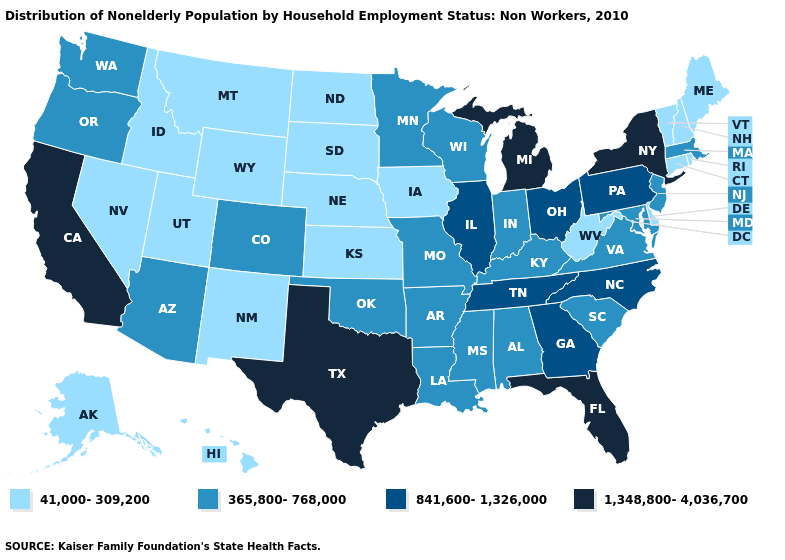What is the lowest value in the Northeast?
Answer briefly. 41,000-309,200. Which states have the highest value in the USA?
Keep it brief. California, Florida, Michigan, New York, Texas. Does New York have the highest value in the Northeast?
Give a very brief answer. Yes. Does Texas have the highest value in the USA?
Be succinct. Yes. Does the map have missing data?
Give a very brief answer. No. Name the states that have a value in the range 41,000-309,200?
Answer briefly. Alaska, Connecticut, Delaware, Hawaii, Idaho, Iowa, Kansas, Maine, Montana, Nebraska, Nevada, New Hampshire, New Mexico, North Dakota, Rhode Island, South Dakota, Utah, Vermont, West Virginia, Wyoming. Does Minnesota have the highest value in the USA?
Concise answer only. No. What is the value of Alabama?
Give a very brief answer. 365,800-768,000. How many symbols are there in the legend?
Short answer required. 4. Does Florida have the highest value in the USA?
Be succinct. Yes. Name the states that have a value in the range 1,348,800-4,036,700?
Concise answer only. California, Florida, Michigan, New York, Texas. Does Mississippi have the same value as South Dakota?
Write a very short answer. No. Which states have the highest value in the USA?
Answer briefly. California, Florida, Michigan, New York, Texas. What is the value of Tennessee?
Short answer required. 841,600-1,326,000. What is the value of Oklahoma?
Keep it brief. 365,800-768,000. 